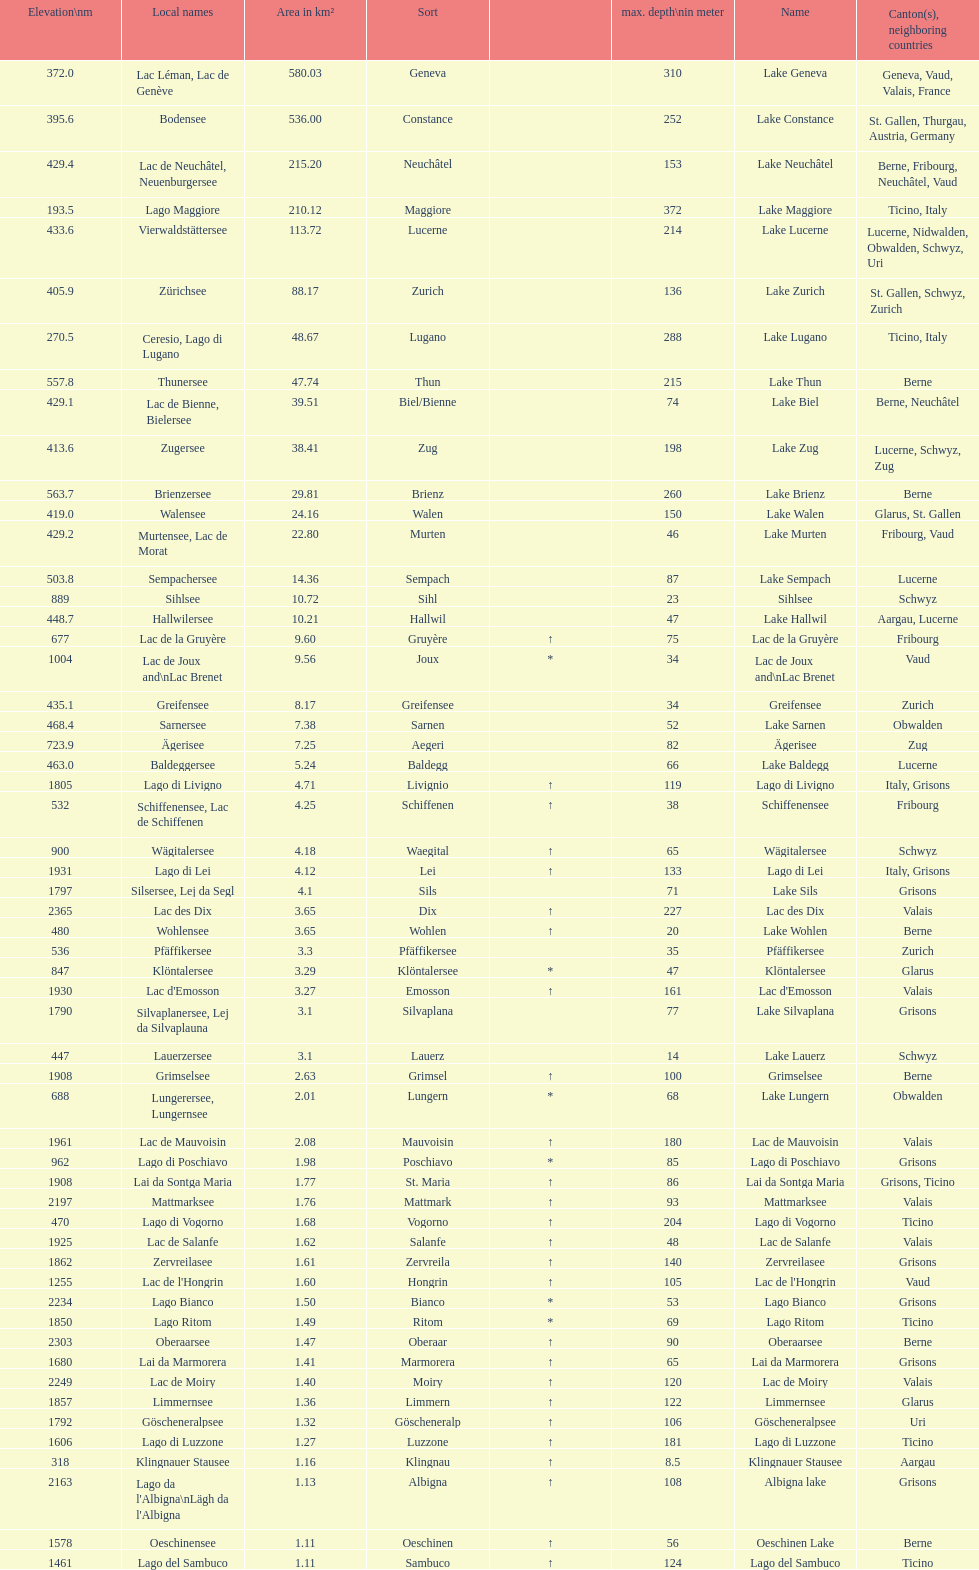Can you parse all the data within this table? {'header': ['Elevation\\nm', 'Local names', 'Area in km²', 'Sort', '', 'max. depth\\nin meter', 'Name', 'Canton(s), neighboring countries'], 'rows': [['372.0', 'Lac Léman, Lac de Genève', '580.03', 'Geneva', '', '310', 'Lake Geneva', 'Geneva, Vaud, Valais, France'], ['395.6', 'Bodensee', '536.00', 'Constance', '', '252', 'Lake Constance', 'St. Gallen, Thurgau, Austria, Germany'], ['429.4', 'Lac de Neuchâtel, Neuenburgersee', '215.20', 'Neuchâtel', '', '153', 'Lake Neuchâtel', 'Berne, Fribourg, Neuchâtel, Vaud'], ['193.5', 'Lago Maggiore', '210.12', 'Maggiore', '', '372', 'Lake Maggiore', 'Ticino, Italy'], ['433.6', 'Vierwaldstättersee', '113.72', 'Lucerne', '', '214', 'Lake Lucerne', 'Lucerne, Nidwalden, Obwalden, Schwyz, Uri'], ['405.9', 'Zürichsee', '88.17', 'Zurich', '', '136', 'Lake Zurich', 'St. Gallen, Schwyz, Zurich'], ['270.5', 'Ceresio, Lago di Lugano', '48.67', 'Lugano', '', '288', 'Lake Lugano', 'Ticino, Italy'], ['557.8', 'Thunersee', '47.74', 'Thun', '', '215', 'Lake Thun', 'Berne'], ['429.1', 'Lac de Bienne, Bielersee', '39.51', 'Biel/Bienne', '', '74', 'Lake Biel', 'Berne, Neuchâtel'], ['413.6', 'Zugersee', '38.41', 'Zug', '', '198', 'Lake Zug', 'Lucerne, Schwyz, Zug'], ['563.7', 'Brienzersee', '29.81', 'Brienz', '', '260', 'Lake Brienz', 'Berne'], ['419.0', 'Walensee', '24.16', 'Walen', '', '150', 'Lake Walen', 'Glarus, St. Gallen'], ['429.2', 'Murtensee, Lac de Morat', '22.80', 'Murten', '', '46', 'Lake Murten', 'Fribourg, Vaud'], ['503.8', 'Sempachersee', '14.36', 'Sempach', '', '87', 'Lake Sempach', 'Lucerne'], ['889', 'Sihlsee', '10.72', 'Sihl', '', '23', 'Sihlsee', 'Schwyz'], ['448.7', 'Hallwilersee', '10.21', 'Hallwil', '', '47', 'Lake Hallwil', 'Aargau, Lucerne'], ['677', 'Lac de la Gruyère', '9.60', 'Gruyère', '↑', '75', 'Lac de la Gruyère', 'Fribourg'], ['1004', 'Lac de Joux and\\nLac Brenet', '9.56', 'Joux', '*', '34', 'Lac de Joux and\\nLac Brenet', 'Vaud'], ['435.1', 'Greifensee', '8.17', 'Greifensee', '', '34', 'Greifensee', 'Zurich'], ['468.4', 'Sarnersee', '7.38', 'Sarnen', '', '52', 'Lake Sarnen', 'Obwalden'], ['723.9', 'Ägerisee', '7.25', 'Aegeri', '', '82', 'Ägerisee', 'Zug'], ['463.0', 'Baldeggersee', '5.24', 'Baldegg', '', '66', 'Lake Baldegg', 'Lucerne'], ['1805', 'Lago di Livigno', '4.71', 'Livignio', '↑', '119', 'Lago di Livigno', 'Italy, Grisons'], ['532', 'Schiffenensee, Lac de Schiffenen', '4.25', 'Schiffenen', '↑', '38', 'Schiffenensee', 'Fribourg'], ['900', 'Wägitalersee', '4.18', 'Waegital', '↑', '65', 'Wägitalersee', 'Schwyz'], ['1931', 'Lago di Lei', '4.12', 'Lei', '↑', '133', 'Lago di Lei', 'Italy, Grisons'], ['1797', 'Silsersee, Lej da Segl', '4.1', 'Sils', '', '71', 'Lake Sils', 'Grisons'], ['2365', 'Lac des Dix', '3.65', 'Dix', '↑', '227', 'Lac des Dix', 'Valais'], ['480', 'Wohlensee', '3.65', 'Wohlen', '↑', '20', 'Lake Wohlen', 'Berne'], ['536', 'Pfäffikersee', '3.3', 'Pfäffikersee', '', '35', 'Pfäffikersee', 'Zurich'], ['847', 'Klöntalersee', '3.29', 'Klöntalersee', '*', '47', 'Klöntalersee', 'Glarus'], ['1930', "Lac d'Emosson", '3.27', 'Emosson', '↑', '161', "Lac d'Emosson", 'Valais'], ['1790', 'Silvaplanersee, Lej da Silvaplauna', '3.1', 'Silvaplana', '', '77', 'Lake Silvaplana', 'Grisons'], ['447', 'Lauerzersee', '3.1', 'Lauerz', '', '14', 'Lake Lauerz', 'Schwyz'], ['1908', 'Grimselsee', '2.63', 'Grimsel', '↑', '100', 'Grimselsee', 'Berne'], ['688', 'Lungerersee, Lungernsee', '2.01', 'Lungern', '*', '68', 'Lake Lungern', 'Obwalden'], ['1961', 'Lac de Mauvoisin', '2.08', 'Mauvoisin', '↑', '180', 'Lac de Mauvoisin', 'Valais'], ['962', 'Lago di Poschiavo', '1.98', 'Poschiavo', '*', '85', 'Lago di Poschiavo', 'Grisons'], ['1908', 'Lai da Sontga Maria', '1.77', 'St. Maria', '↑', '86', 'Lai da Sontga Maria', 'Grisons, Ticino'], ['2197', 'Mattmarksee', '1.76', 'Mattmark', '↑', '93', 'Mattmarksee', 'Valais'], ['470', 'Lago di Vogorno', '1.68', 'Vogorno', '↑', '204', 'Lago di Vogorno', 'Ticino'], ['1925', 'Lac de Salanfe', '1.62', 'Salanfe', '↑', '48', 'Lac de Salanfe', 'Valais'], ['1862', 'Zervreilasee', '1.61', 'Zervreila', '↑', '140', 'Zervreilasee', 'Grisons'], ['1255', "Lac de l'Hongrin", '1.60', 'Hongrin', '↑', '105', "Lac de l'Hongrin", 'Vaud'], ['2234', 'Lago Bianco', '1.50', 'Bianco', '*', '53', 'Lago Bianco', 'Grisons'], ['1850', 'Lago Ritom', '1.49', 'Ritom', '*', '69', 'Lago Ritom', 'Ticino'], ['2303', 'Oberaarsee', '1.47', 'Oberaar', '↑', '90', 'Oberaarsee', 'Berne'], ['1680', 'Lai da Marmorera', '1.41', 'Marmorera', '↑', '65', 'Lai da Marmorera', 'Grisons'], ['2249', 'Lac de Moiry', '1.40', 'Moiry', '↑', '120', 'Lac de Moiry', 'Valais'], ['1857', 'Limmernsee', '1.36', 'Limmern', '↑', '122', 'Limmernsee', 'Glarus'], ['1792', 'Göscheneralpsee', '1.32', 'Göscheneralp', '↑', '106', 'Göscheneralpsee', 'Uri'], ['1606', 'Lago di Luzzone', '1.27', 'Luzzone', '↑', '181', 'Lago di Luzzone', 'Ticino'], ['318', 'Klingnauer Stausee', '1.16', 'Klingnau', '↑', '8.5', 'Klingnauer Stausee', 'Aargau'], ['2163', "Lago da l'Albigna\\nLägh da l'Albigna", '1.13', 'Albigna', '↑', '108', 'Albigna lake', 'Grisons'], ['1578', 'Oeschinensee', '1.11', 'Oeschinen', '↑', '56', 'Oeschinen Lake', 'Berne'], ['1461', 'Lago del Sambuco', '1.11', 'Sambuco', '↑', '124', 'Lago del Sambuco', 'Ticino']]} What is the complete area in km² of lake sils? 4.1. 